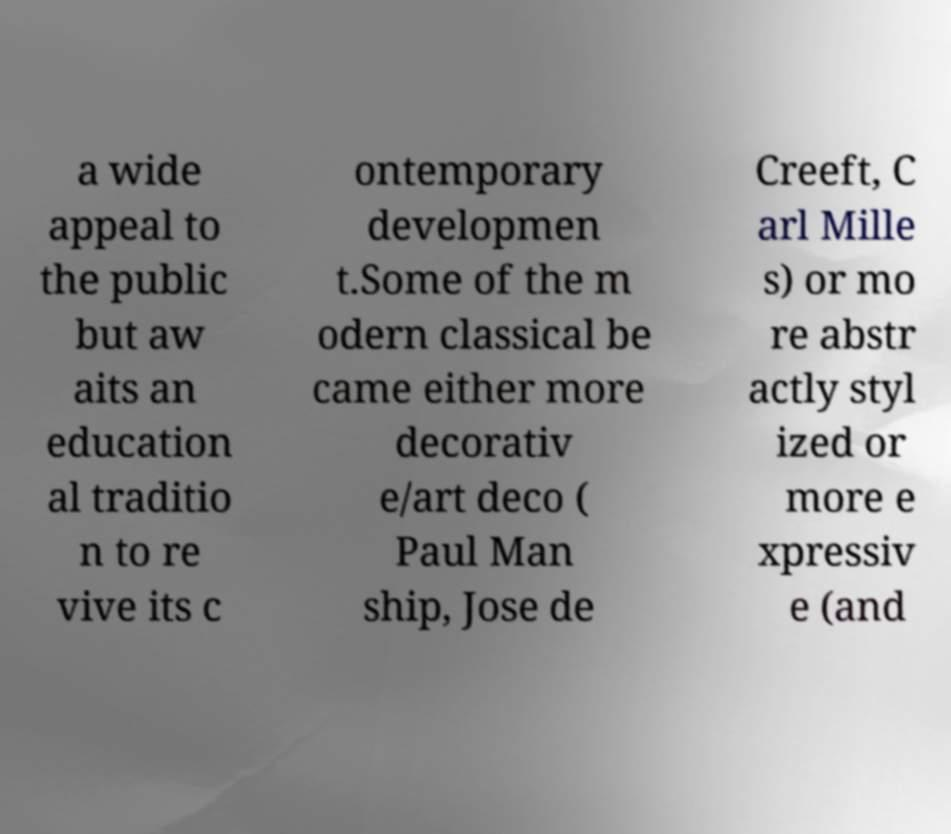There's text embedded in this image that I need extracted. Can you transcribe it verbatim? a wide appeal to the public but aw aits an education al traditio n to re vive its c ontemporary developmen t.Some of the m odern classical be came either more decorativ e/art deco ( Paul Man ship, Jose de Creeft, C arl Mille s) or mo re abstr actly styl ized or more e xpressiv e (and 